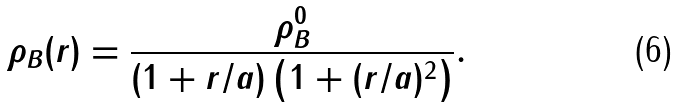<formula> <loc_0><loc_0><loc_500><loc_500>\rho _ { B } ( r ) = \frac { \rho _ { B } ^ { 0 } } { ( 1 + r / a ) \left ( 1 + ( r / a ) ^ { 2 } \right ) } .</formula> 